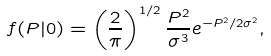Convert formula to latex. <formula><loc_0><loc_0><loc_500><loc_500>f ( P | 0 ) = \left ( \frac { 2 } { \pi } \right ) ^ { 1 / 2 } \frac { P ^ { 2 } } { \sigma ^ { 3 } } e ^ { - P ^ { 2 } / 2 \sigma ^ { 2 } } ,</formula> 